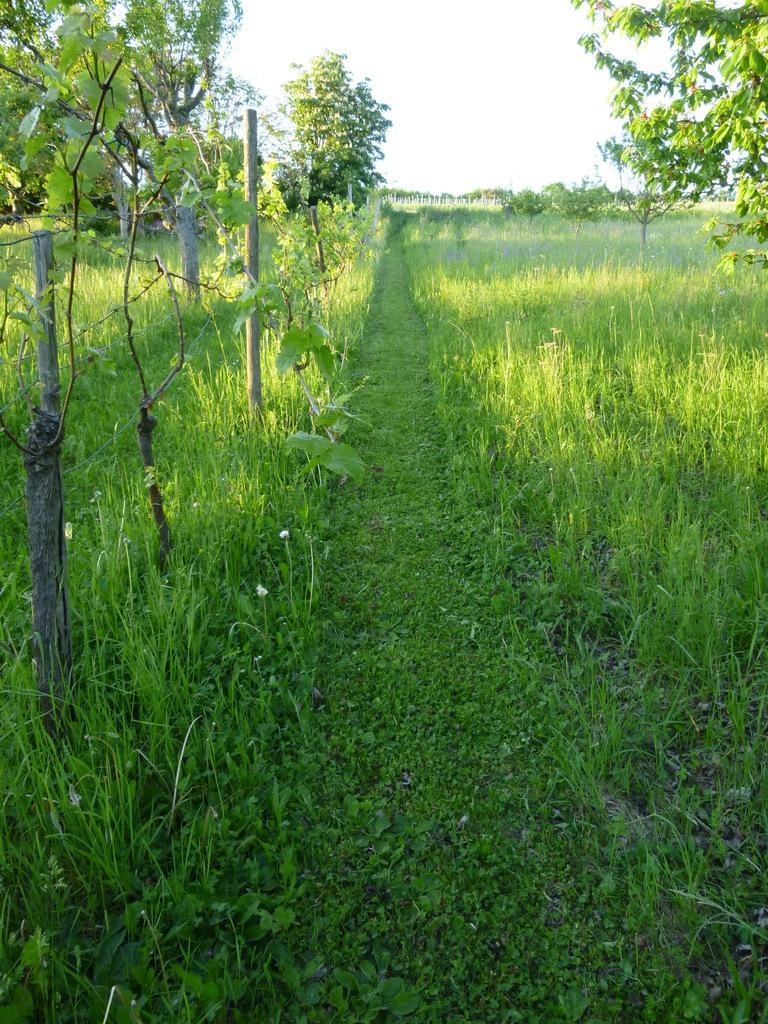Could you give a brief overview of what you see in this image? In this image there is grass, few plants and some trees are on the land. Left side there is a fence. Top of image there is sky. 